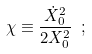<formula> <loc_0><loc_0><loc_500><loc_500>\chi \equiv \frac { \dot { X } _ { 0 } ^ { 2 } } { 2 X _ { 0 } ^ { 2 } } \ ;</formula> 